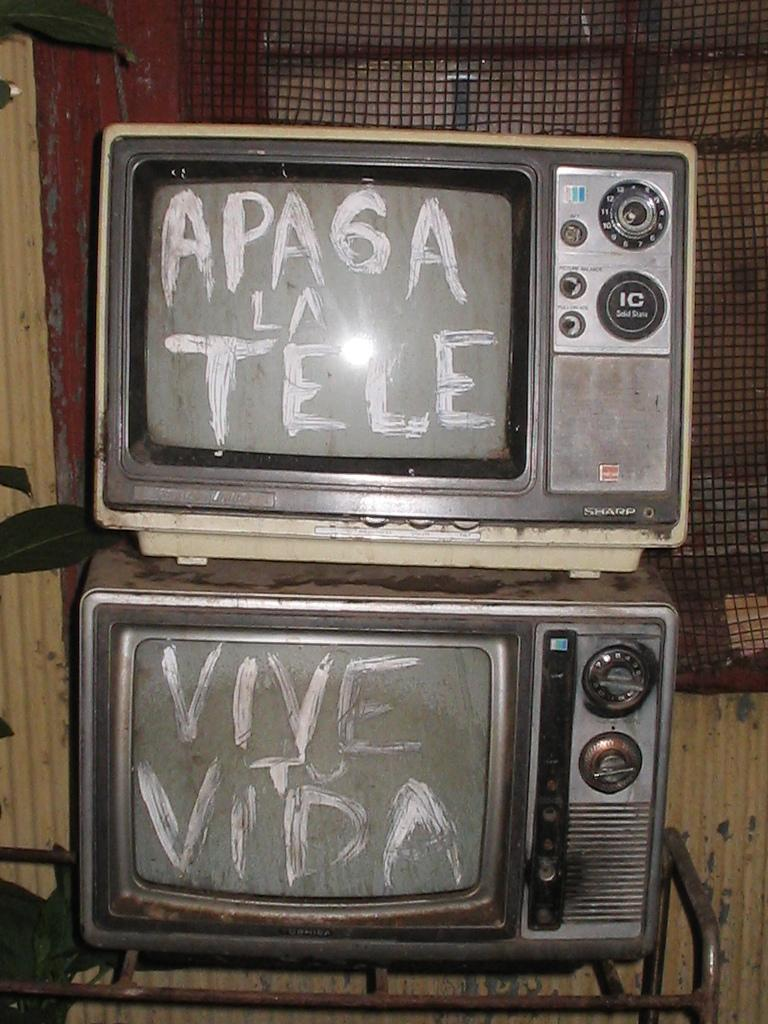<image>
Write a terse but informative summary of the picture. Two old fashioned televisions, one of which has the word Vive written on it. 